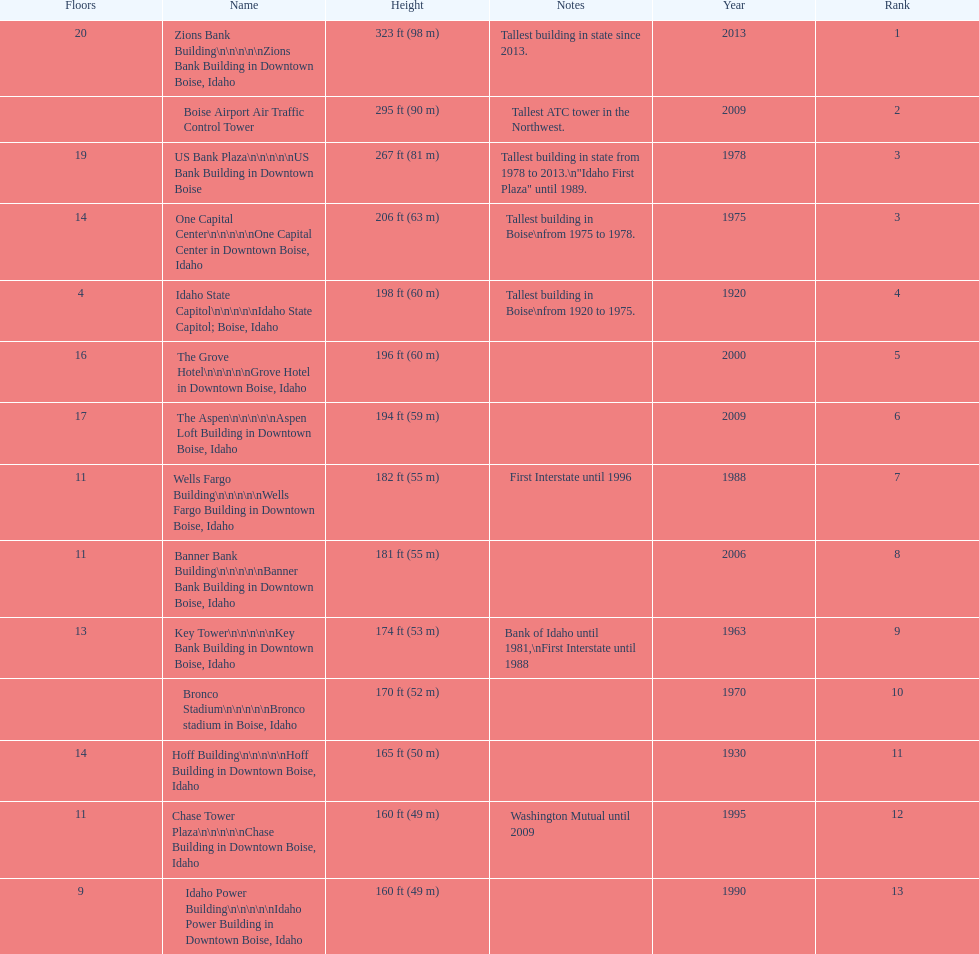Which building has the most floors according to this chart? Zions Bank Building. 